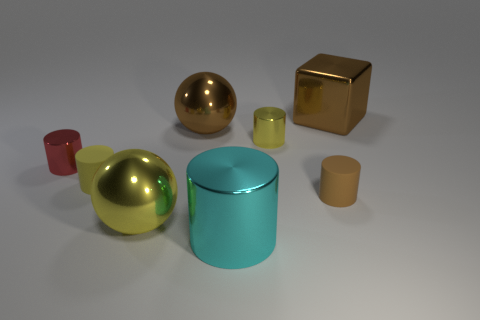Subtract all yellow cylinders. How many cylinders are left? 3 Subtract all yellow cylinders. How many cylinders are left? 3 Add 1 small brown matte spheres. How many objects exist? 9 Subtract all blue cylinders. Subtract all blue spheres. How many cylinders are left? 5 Subtract all blocks. How many objects are left? 7 Add 1 tiny brown things. How many tiny brown things exist? 2 Subtract 1 yellow spheres. How many objects are left? 7 Subtract all blue shiny spheres. Subtract all brown shiny objects. How many objects are left? 6 Add 7 big brown shiny objects. How many big brown shiny objects are left? 9 